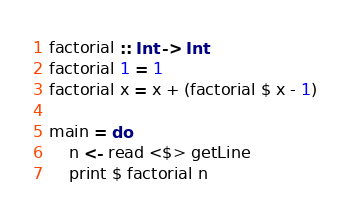<code> <loc_0><loc_0><loc_500><loc_500><_Haskell_>factorial :: Int -> Int
factorial 1 = 1
factorial x = x + (factorial $ x - 1)

main = do
    n <- read <$> getLine
    print $ factorial n</code> 